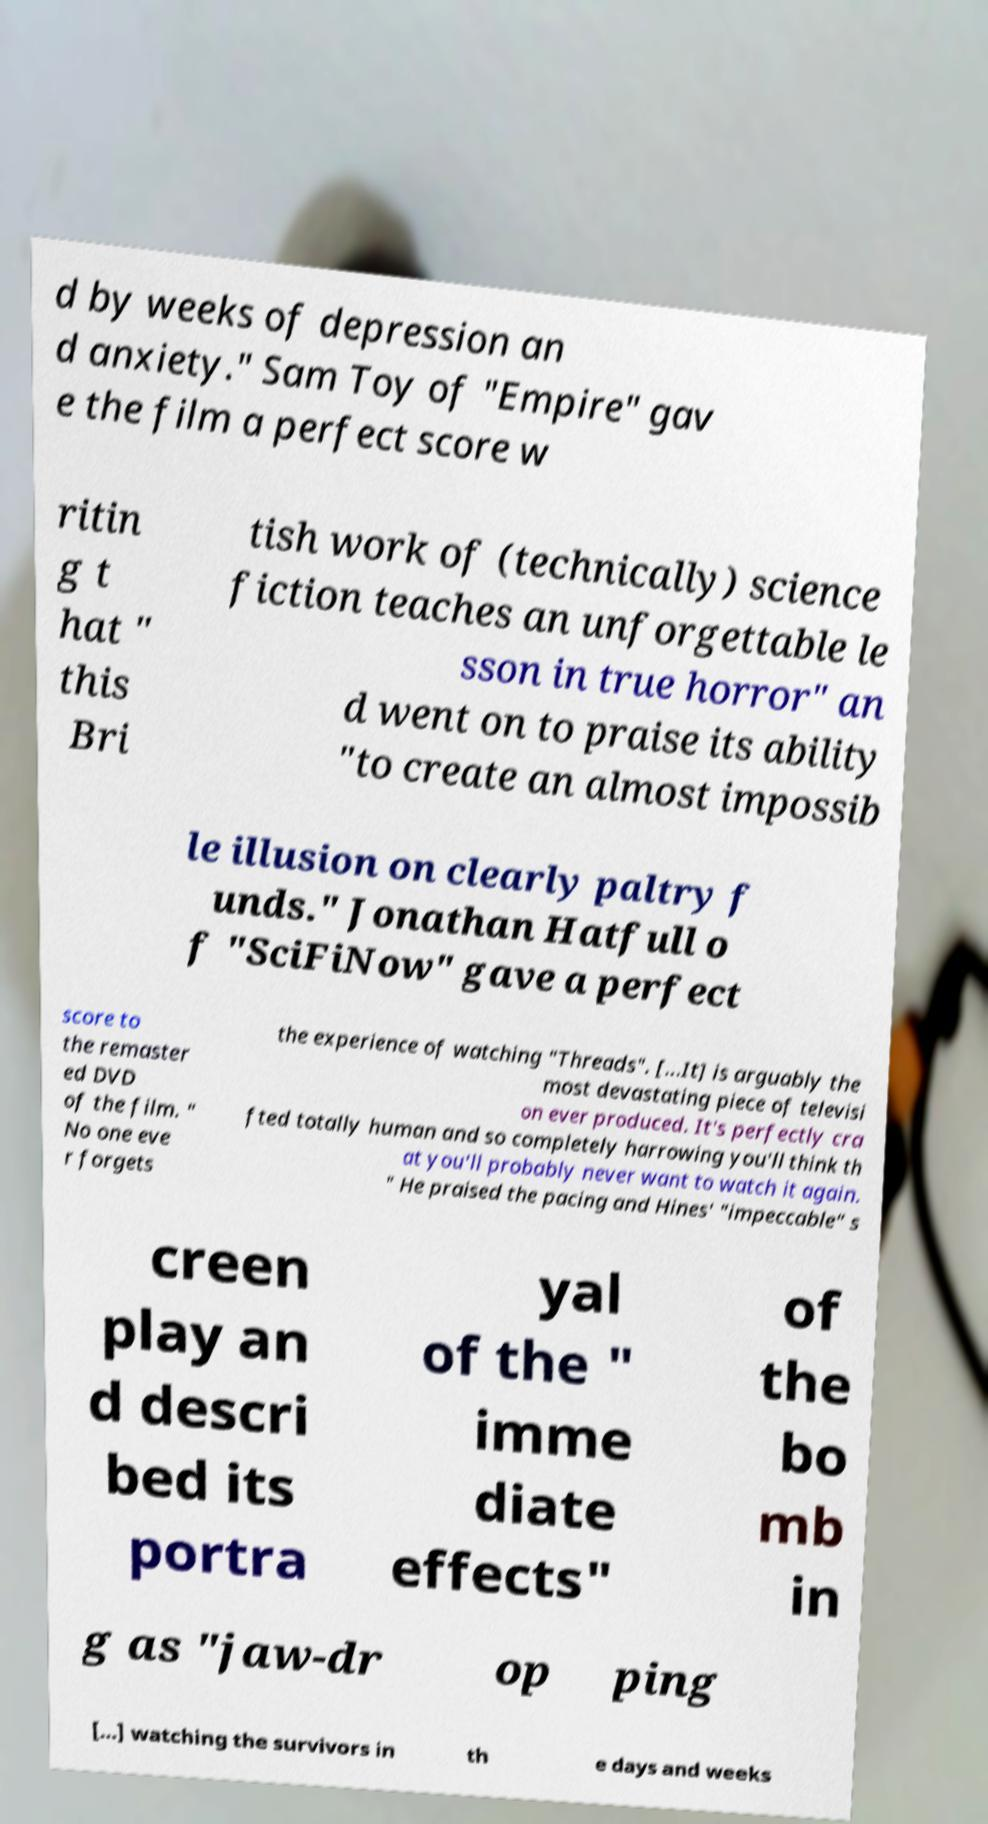Please read and relay the text visible in this image. What does it say? d by weeks of depression an d anxiety." Sam Toy of "Empire" gav e the film a perfect score w ritin g t hat " this Bri tish work of (technically) science fiction teaches an unforgettable le sson in true horror" an d went on to praise its ability "to create an almost impossib le illusion on clearly paltry f unds." Jonathan Hatfull o f "SciFiNow" gave a perfect score to the remaster ed DVD of the film. " No one eve r forgets the experience of watching "Threads". [...It] is arguably the most devastating piece of televisi on ever produced. It's perfectly cra fted totally human and so completely harrowing you'll think th at you'll probably never want to watch it again. " He praised the pacing and Hines' "impeccable" s creen play an d descri bed its portra yal of the " imme diate effects" of the bo mb in g as "jaw-dr op ping [...] watching the survivors in th e days and weeks 